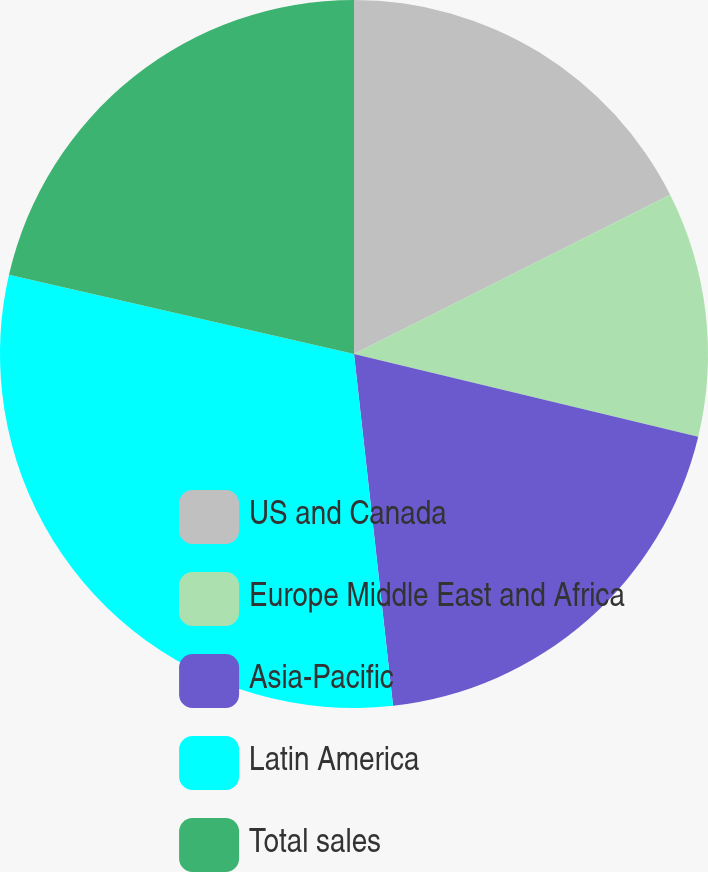Convert chart to OTSL. <chart><loc_0><loc_0><loc_500><loc_500><pie_chart><fcel>US and Canada<fcel>Europe Middle East and Africa<fcel>Asia-Pacific<fcel>Latin America<fcel>Total sales<nl><fcel>17.57%<fcel>11.18%<fcel>19.49%<fcel>30.35%<fcel>21.41%<nl></chart> 